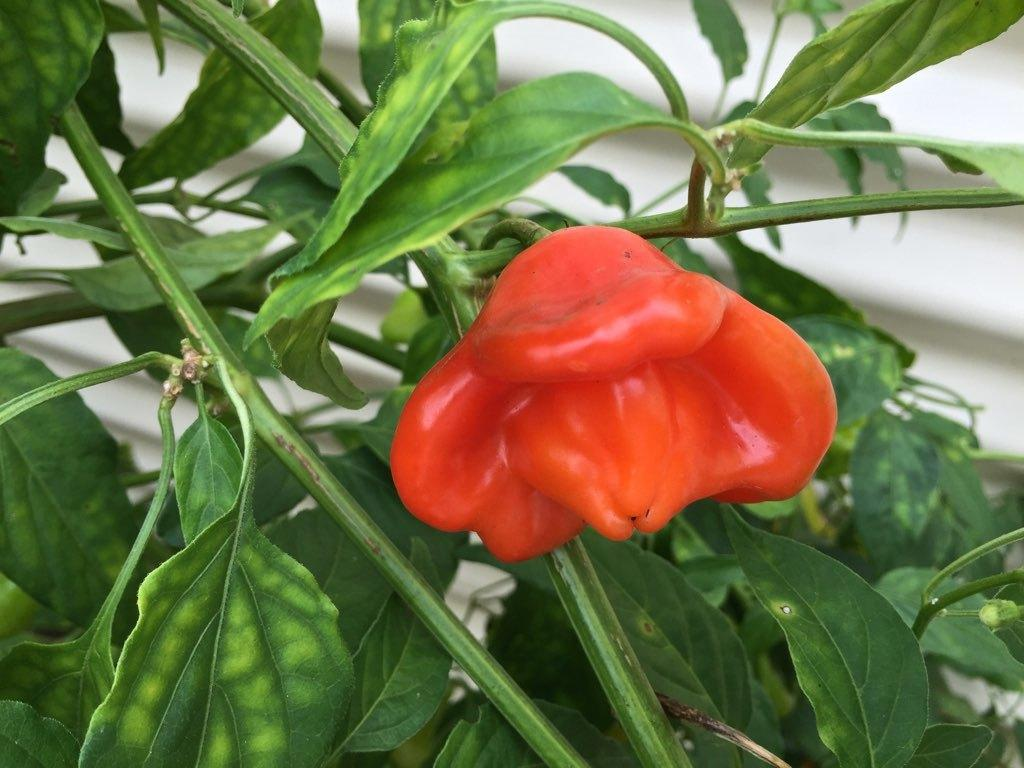What is present in the image? There is a plant in the image. What can be found on the plant? The plant has a vegetable. What type of jewel can be seen on the plant in the image? There is no jewel present on the plant in the image. What answer does the plant provide in the image? The plant does not provide an answer in the image, as it is a living organism and not capable of answering questions. 